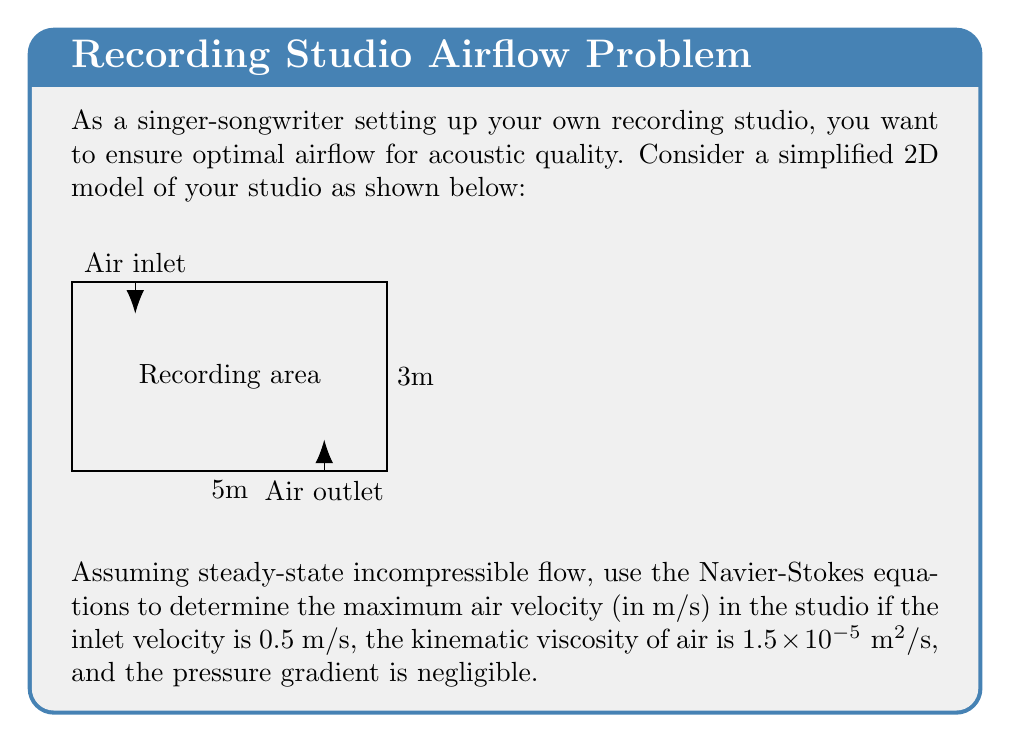Can you solve this math problem? Let's approach this step-by-step:

1) The 2D steady-state incompressible Navier-Stokes equations are:

   $$u\frac{\partial u}{\partial x} + v\frac{\partial u}{\partial y} = -\frac{1}{\rho}\frac{\partial p}{\partial x} + \nu(\frac{\partial^2 u}{\partial x^2} + \frac{\partial^2 u}{\partial y^2})$$
   $$u\frac{\partial v}{\partial x} + v\frac{\partial v}{\partial y} = -\frac{1}{\rho}\frac{\partial p}{\partial y} + \nu(\frac{\partial^2 v}{\partial x^2} + \frac{\partial^2 v}{\partial y^2})$$

   Where $u$ and $v$ are velocity components, $p$ is pressure, $\rho$ is density, and $\nu$ is kinematic viscosity.

2) Given that the pressure gradient is negligible, we can simplify these equations:

   $$u\frac{\partial u}{\partial x} + v\frac{\partial u}{\partial y} = \nu(\frac{\partial^2 u}{\partial x^2} + \frac{\partial^2 u}{\partial y^2})$$
   $$u\frac{\partial v}{\partial x} + v\frac{\partial v}{\partial y} = \nu(\frac{\partial^2 v}{\partial x^2} + \frac{\partial^2 v}{\partial y^2})$$

3) For a first approximation, let's consider the flow along the centerline of the studio. Here, we can assume $v \approx 0$ and $\frac{\partial u}{\partial y} \approx 0$.

4) This further simplifies our equation to:

   $$u\frac{\partial u}{\partial x} = \nu\frac{\partial^2 u}{\partial x^2}$$

5) We can estimate $\frac{\partial u}{\partial x}$ as $\frac{\Delta u}{\Delta x}$, where $\Delta u$ is the change in velocity over the length of the studio.

6) The maximum velocity will occur at the outlet. Let's call this $u_{max}$. Then:

   $$\frac{u_{max}^2 - u_{inlet}^2}{L} \approx \nu\frac{u_{max} - u_{inlet}}{L^2}$$

   Where $L$ is the length of the studio (5m).

7) Substituting the known values:

   $$\frac{u_{max}^2 - 0.5^2}{5} \approx 1.5 \times 10^{-5} \frac{u_{max} - 0.5}{5^2}$$

8) Simplifying:

   $$u_{max}^2 - 0.25 \approx 1.5 \times 10^{-6}(u_{max} - 0.5)$$

9) This is a quadratic equation. Solving it:

   $$u_{max} \approx 0.5018 \text{ m/s}$$
Answer: $0.5018 \text{ m/s}$ 